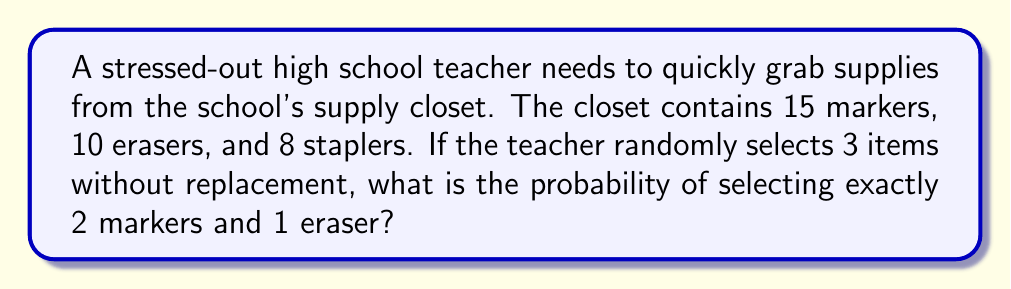Show me your answer to this math problem. Let's approach this step-by-step:

1) First, we need to calculate the total number of ways to select 3 items from 33 items (15 + 10 + 8 = 33). This can be done using the combination formula:

   $$\binom{33}{3} = \frac{33!}{3!(33-3)!} = \frac{33!}{3!30!} = 5456$$

2) Now, we need to calculate the number of ways to select 2 markers out of 15 and 1 eraser out of 10:

   For markers: $$\binom{15}{2} = \frac{15!}{2!(15-2)!} = \frac{15!}{2!13!} = 105$$

   For erasers: $$\binom{10}{1} = \frac{10!}{1!(10-1)!} = \frac{10!}{1!9!} = 10$$

3) By the Multiplication Principle, the number of ways to select 2 markers and 1 eraser is:

   $$105 \times 10 = 1050$$

4) The probability is then the number of favorable outcomes divided by the total number of possible outcomes:

   $$P(\text{2 markers and 1 eraser}) = \frac{1050}{5456} = \frac{525}{2728} \approx 0.1924$$
Answer: $\frac{525}{2728}$ 